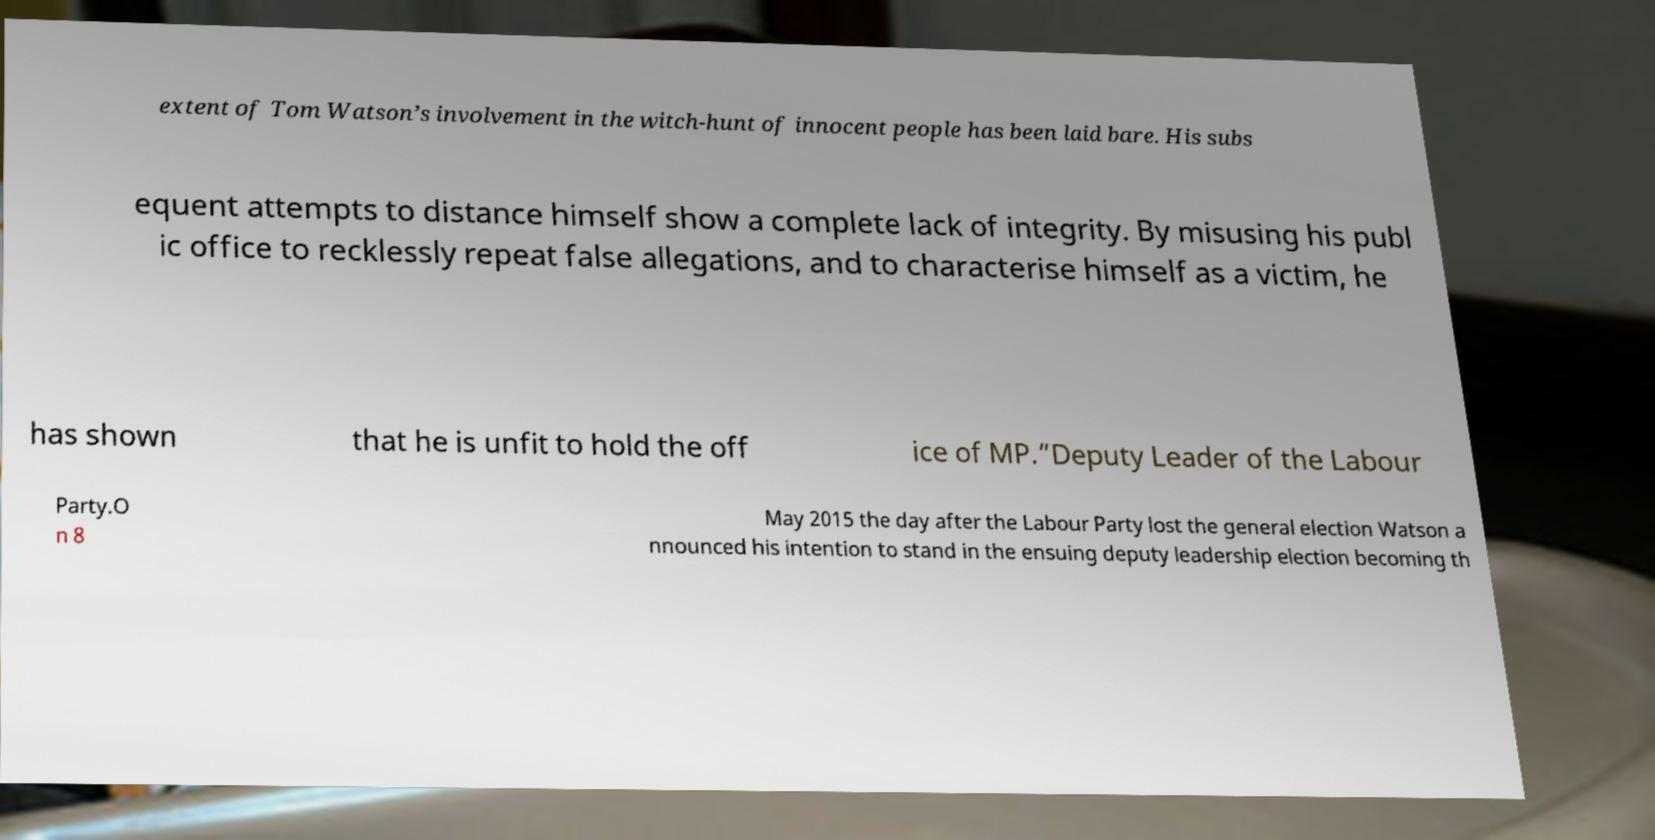Could you assist in decoding the text presented in this image and type it out clearly? extent of Tom Watson’s involvement in the witch-hunt of innocent people has been laid bare. His subs equent attempts to distance himself show a complete lack of integrity. By misusing his publ ic office to recklessly repeat false allegations, and to characterise himself as a victim, he has shown that he is unfit to hold the off ice of MP.”Deputy Leader of the Labour Party.O n 8 May 2015 the day after the Labour Party lost the general election Watson a nnounced his intention to stand in the ensuing deputy leadership election becoming th 